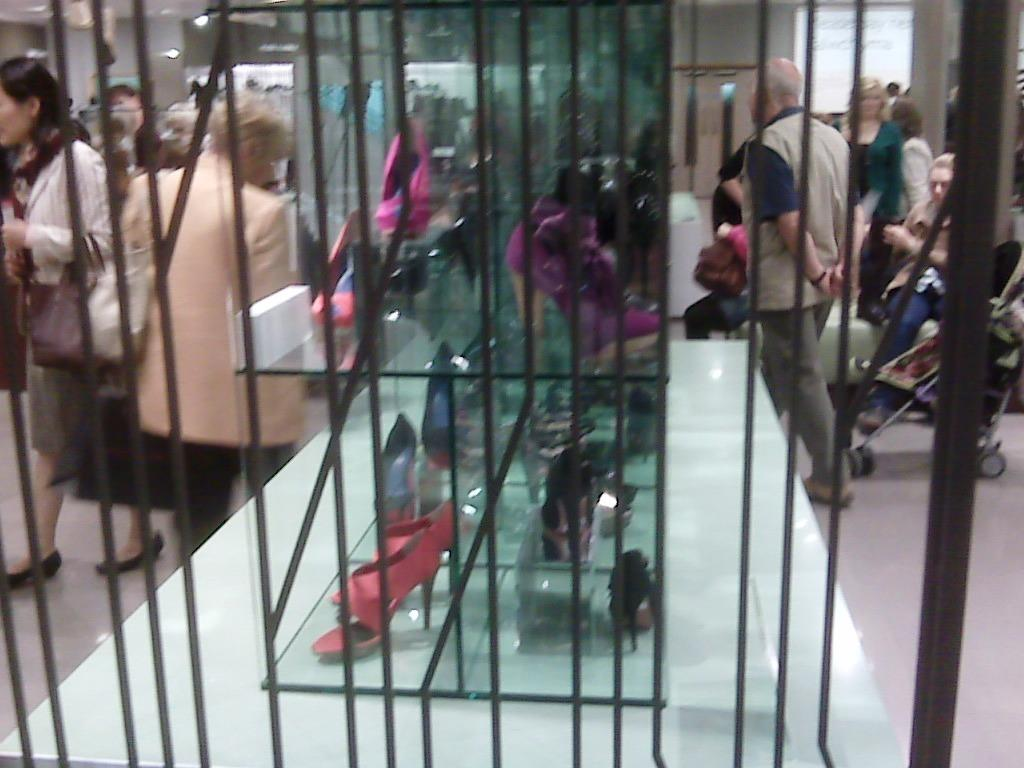What is the general activity of the people in the image? There are people standing in the image, which suggests they might be observing or interacting with something. What is the position of the woman in the image? There is a woman seated in the image. What type of item is displayed in a glass box in the image? There are women's footwear in a glass box in the image. What object is present for transporting a baby in the image? There is a baby trolley in the image. What type of tongue can be seen sticking out of the baby trolley in the image? There is no tongue visible in the image, as it features people, a seated woman, women's footwear in a glass box, and a baby trolley. 